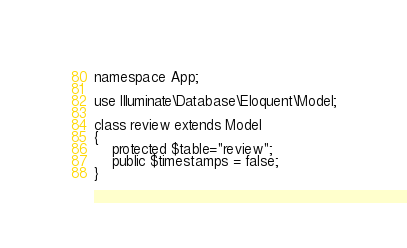<code> <loc_0><loc_0><loc_500><loc_500><_PHP_>
namespace App;

use Illuminate\Database\Eloquent\Model;

class review extends Model
{
    protected $table="review";
    public $timestamps = false;
}
</code> 